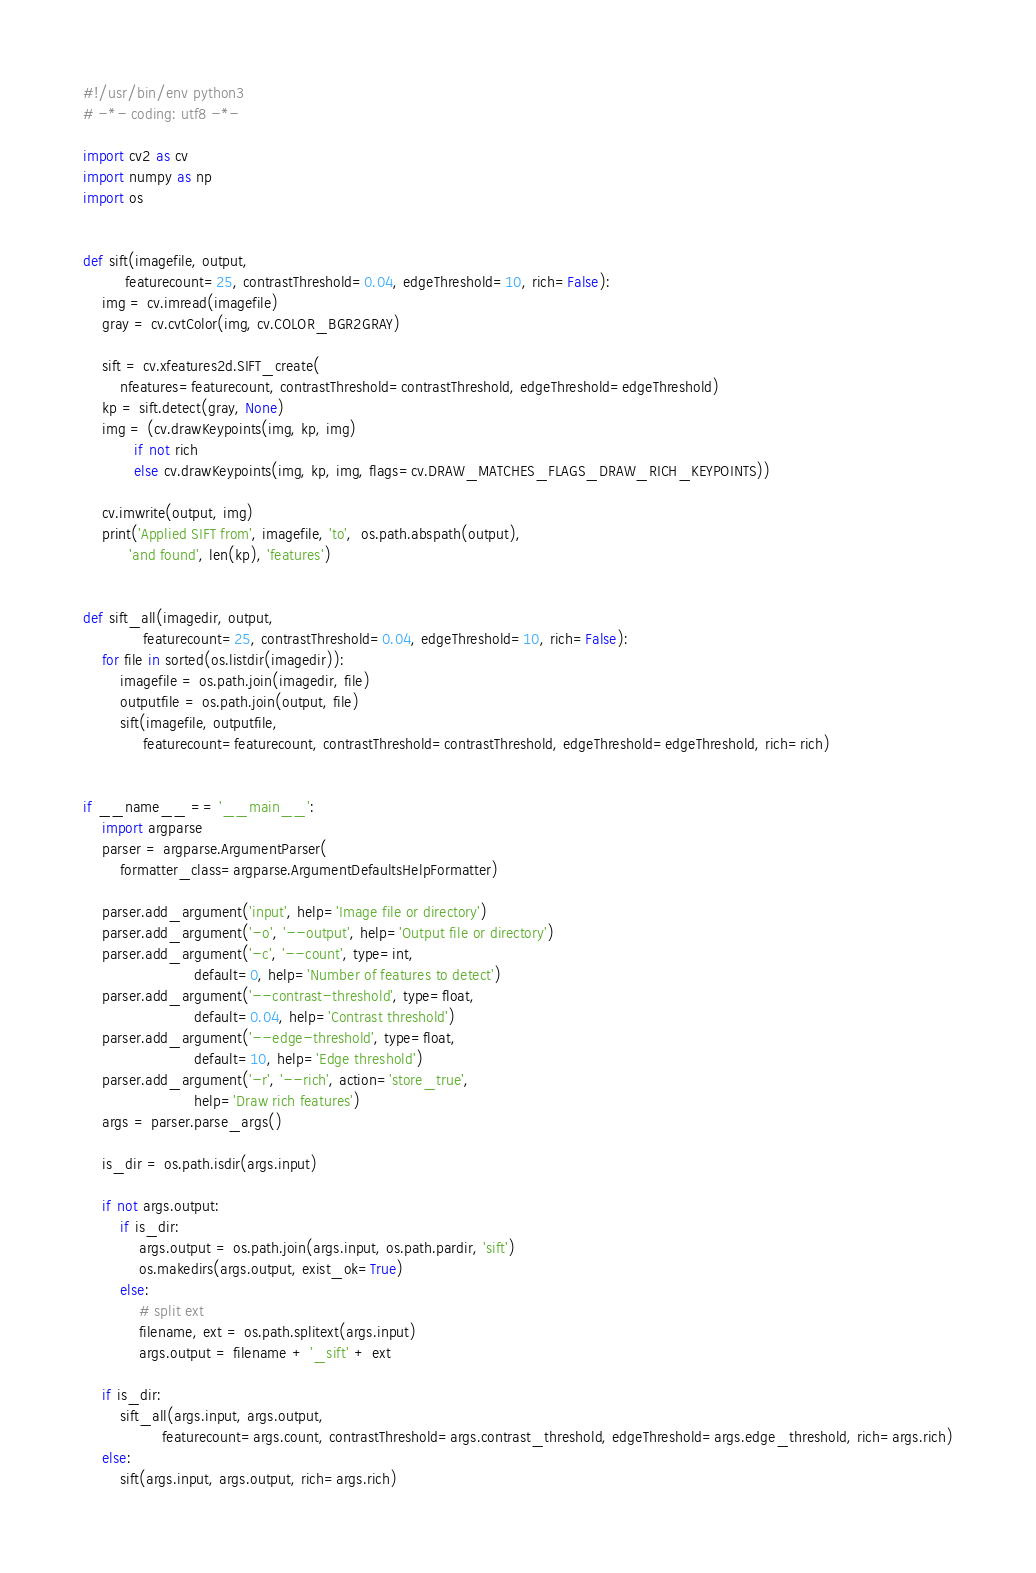Convert code to text. <code><loc_0><loc_0><loc_500><loc_500><_Python_>#!/usr/bin/env python3
# -*- coding: utf8 -*-

import cv2 as cv
import numpy as np
import os


def sift(imagefile, output,
         featurecount=25, contrastThreshold=0.04, edgeThreshold=10, rich=False):
    img = cv.imread(imagefile)
    gray = cv.cvtColor(img, cv.COLOR_BGR2GRAY)

    sift = cv.xfeatures2d.SIFT_create(
        nfeatures=featurecount, contrastThreshold=contrastThreshold, edgeThreshold=edgeThreshold)
    kp = sift.detect(gray, None)
    img = (cv.drawKeypoints(img, kp, img)
           if not rich
           else cv.drawKeypoints(img, kp, img, flags=cv.DRAW_MATCHES_FLAGS_DRAW_RICH_KEYPOINTS))

    cv.imwrite(output, img)
    print('Applied SIFT from', imagefile, 'to',  os.path.abspath(output),
          'and found', len(kp), 'features')


def sift_all(imagedir, output,
             featurecount=25, contrastThreshold=0.04, edgeThreshold=10, rich=False):
    for file in sorted(os.listdir(imagedir)):
        imagefile = os.path.join(imagedir, file)
        outputfile = os.path.join(output, file)
        sift(imagefile, outputfile,
             featurecount=featurecount, contrastThreshold=contrastThreshold, edgeThreshold=edgeThreshold, rich=rich)


if __name__ == '__main__':
    import argparse
    parser = argparse.ArgumentParser(
        formatter_class=argparse.ArgumentDefaultsHelpFormatter)

    parser.add_argument('input', help='Image file or directory')
    parser.add_argument('-o', '--output', help='Output file or directory')
    parser.add_argument('-c', '--count', type=int,
                        default=0, help='Number of features to detect')
    parser.add_argument('--contrast-threshold', type=float,
                        default=0.04, help='Contrast threshold')
    parser.add_argument('--edge-threshold', type=float,
                        default=10, help='Edge threshold')
    parser.add_argument('-r', '--rich', action='store_true',
                        help='Draw rich features')
    args = parser.parse_args()

    is_dir = os.path.isdir(args.input)

    if not args.output:
        if is_dir:
            args.output = os.path.join(args.input, os.path.pardir, 'sift')
            os.makedirs(args.output, exist_ok=True)
        else:
            # split ext
            filename, ext = os.path.splitext(args.input)
            args.output = filename + '_sift' + ext

    if is_dir:
        sift_all(args.input, args.output,
                 featurecount=args.count, contrastThreshold=args.contrast_threshold, edgeThreshold=args.edge_threshold, rich=args.rich)
    else:
        sift(args.input, args.output, rich=args.rich)
</code> 